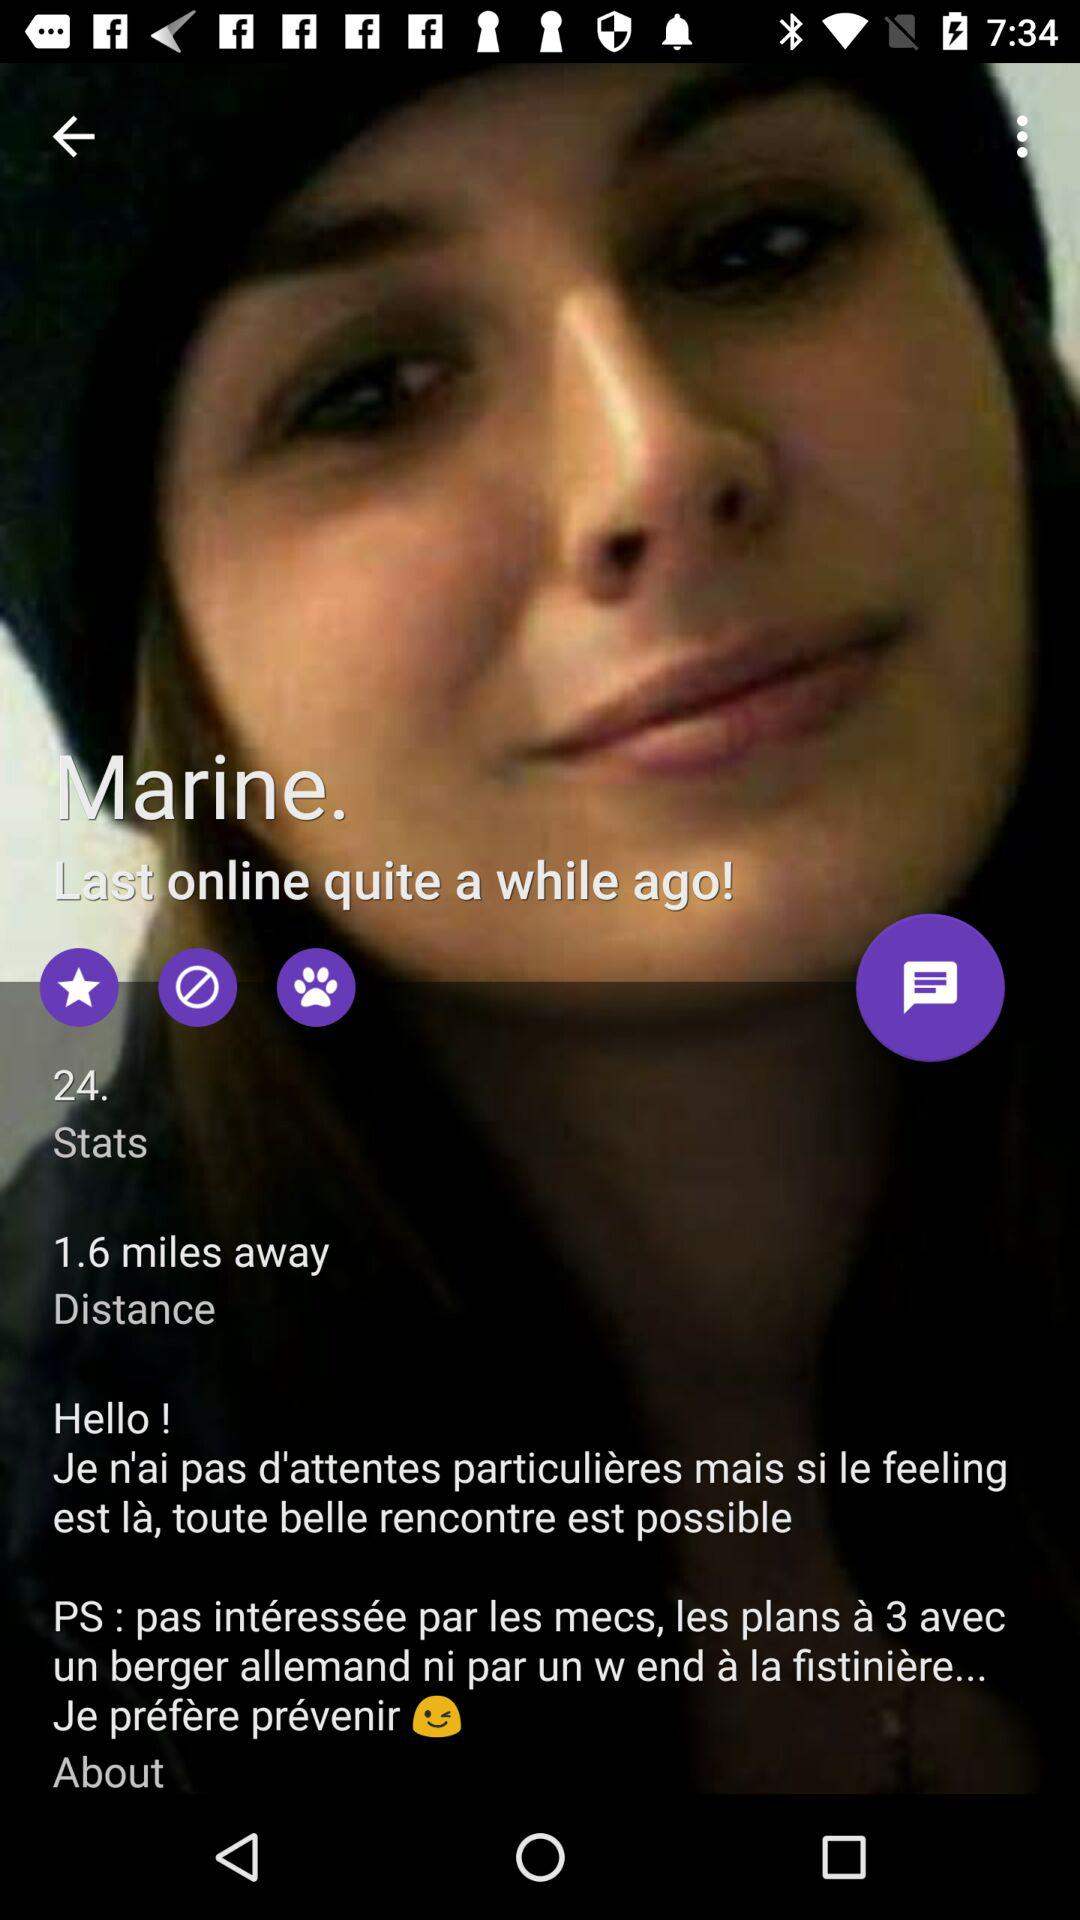When was the last time Marine was online? Marine was last online quite a while ago. 